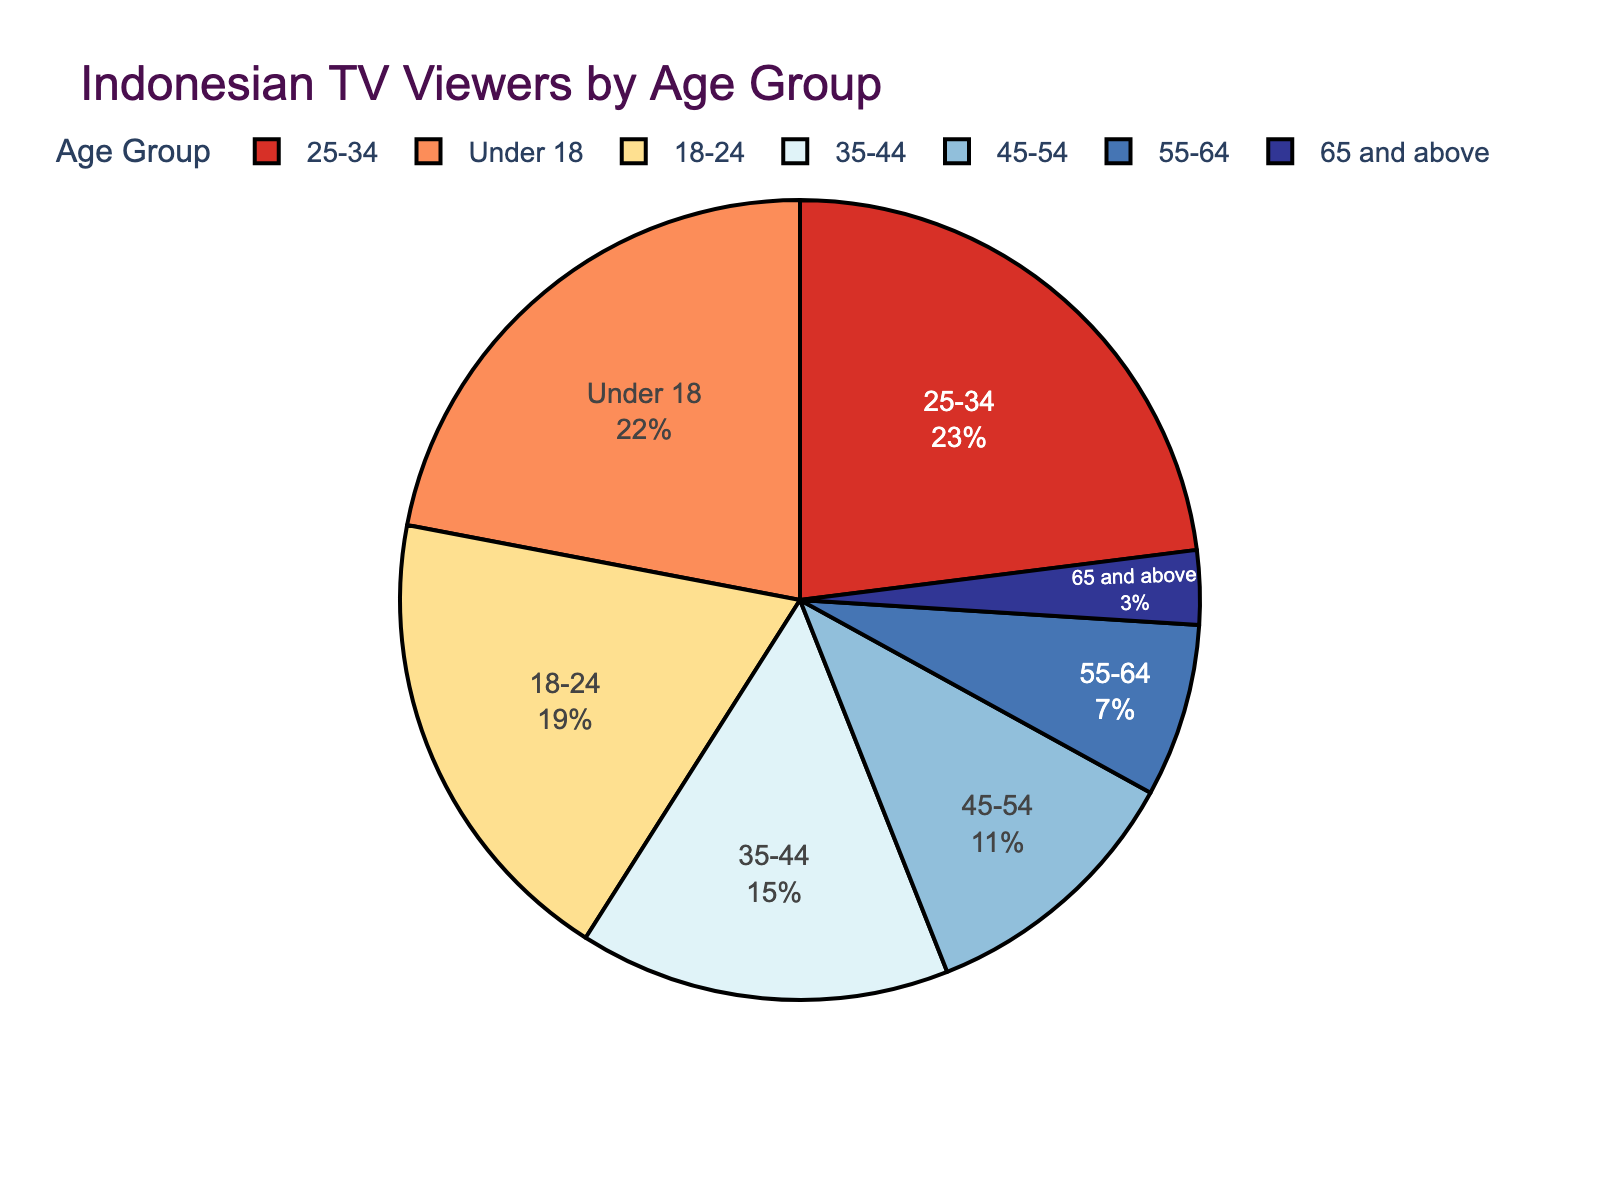What age group has the highest percentage of television viewers? The pie chart shows different age groups and their corresponding percentages. The age group 25-34 has the highest percentage at 23%.
Answer: 25-34 What is the combined percentage of viewers aged 35-64? Sum the percentages of the age groups 35-44, 45-54, and 55-64. This is 15% + 11% + 7% = 33%.
Answer: 33% Which age group has a smaller percentage of viewers, 18-24 or 45-54? Compare the percentages of age groups 18-24 and 45-54. The age group 45-54 has 11%, which is smaller than the 19% for the age group 18-24.
Answer: 45-54 What percentage of viewers are under 18 years old? The pie chart explicitly shows the percentage of the under 18 age group as 22%.
Answer: 22% Is the percentage of viewers aged 65 and above more or less than half of the percentage of viewers aged 18-24? Compare the percentages of viewers aged 65 and above and 18-24. Half of 19% (18-24) is 9.5%. Since the 65 and above group has 3%, it is less than 9.5%.
Answer: Less Which two age groups combined make up approximately the same percentage of viewers as the 25-34 age group? Compare the percentage of viewers in the 25-34 age group (23%) to the combined percentages of other age groups. The 18-24 (19%) and 65 and above (3%) combined make 22%, which is approximately 23%.
Answer: 18-24 and 65 and above What is the difference in percentage points between the 18-24 and 25-34 age groups? Subtract the percentage of the 18-24 group (19%) from the 25-34 group (23%). This gives 23% - 19% = 4%.
Answer: 4% What is the most common color used in the pie chart? The pie chart uses a custom color palette. According to the data and color sequence, the color #D73027 (Red) is the largest segment and corresponds to the 25-34 age group. Hence, Red is the most common color.
Answer: Red How many age groups have a percentage of viewers greater than or equal to 15%? Identify the age groups with percentages >= 15%. These are Under 18 (22%), 18-24 (19%), and 25-34 (23%), and 35-44 (15%). This makes 4 age groups.
Answer: 4 